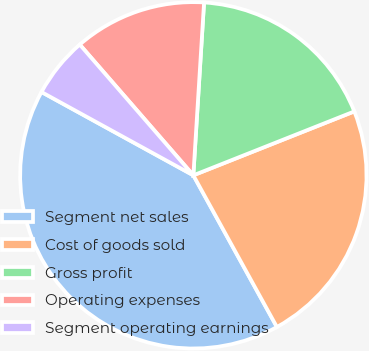Convert chart to OTSL. <chart><loc_0><loc_0><loc_500><loc_500><pie_chart><fcel>Segment net sales<fcel>Cost of goods sold<fcel>Gross profit<fcel>Operating expenses<fcel>Segment operating earnings<nl><fcel>41.0%<fcel>23.0%<fcel>18.0%<fcel>12.37%<fcel>5.63%<nl></chart> 